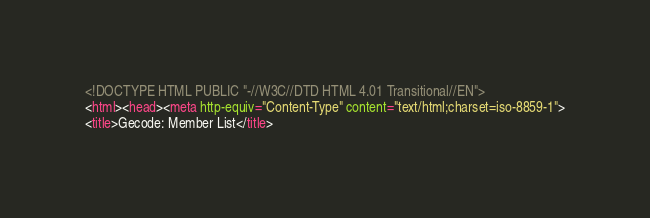Convert code to text. <code><loc_0><loc_0><loc_500><loc_500><_HTML_><!DOCTYPE HTML PUBLIC "-//W3C//DTD HTML 4.01 Transitional//EN">
<html><head><meta http-equiv="Content-Type" content="text/html;charset=iso-8859-1">
<title>Gecode: Member List</title></code> 